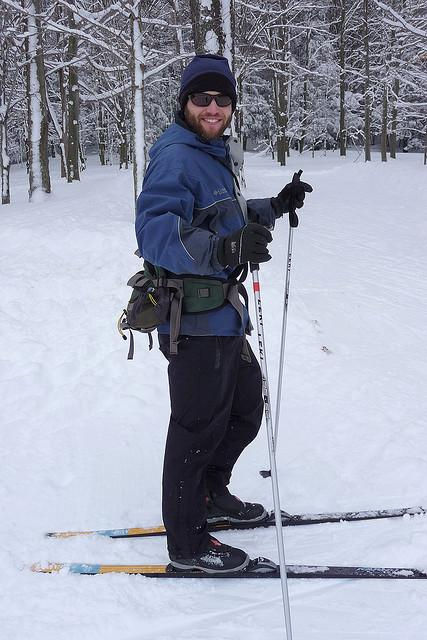What type of skiing is he likely doing? Please explain your reasoning. crosscountry. From the type of foot gear and skis he's wearing, he is crosscountry skiing. 